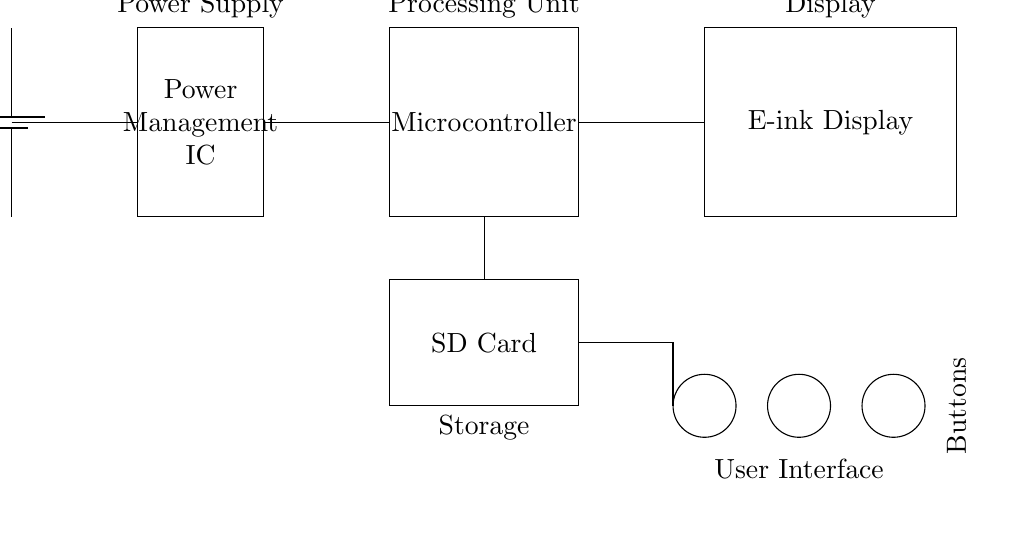What is the voltage of the battery? The voltage is specified within the circuit as 3.7 volts, which is indicated next to the battery symbol.
Answer: 3.7 volts What component acts as the processing unit in this circuit? The circuit shows a rectangle labeled "Microcontroller," which signifies that this component is responsible for processing.
Answer: Microcontroller How many buttons are included in the user interface? The circuit diagram displays three circles, each representing a button, indicating a total of three buttons for user interaction.
Answer: Three What is the purpose of the SD card in the circuit? The SD card is labeled "Storage" in the diagram, which suggests that it is used for storing data, such as the poetry entries in the journal.
Answer: Storage Which component is connected to both the power management IC and the microcontroller? The connections indicate a direct line from the power management IC to the microcontroller, meaning that this component receives power from the management IC.
Answer: Microcontroller Explain how the power from the battery reaches the e-ink display. The battery supplies power to the power management IC, which then routes the power to the microcontroller, and finally, connections show the microcontroller delivering power to the e-ink display, establishing a complete path from the battery to the display.
Answer: Through the microcontroller 